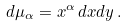<formula> <loc_0><loc_0><loc_500><loc_500>d \mu _ { \alpha } = x ^ { \alpha } \, d x d y \, .</formula> 